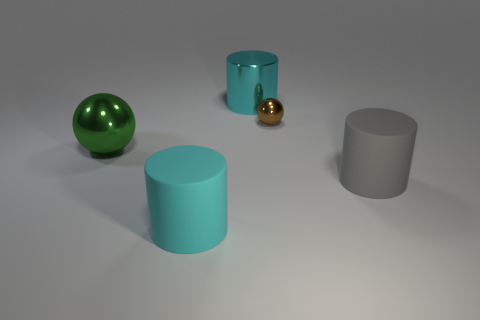What is the material of the other object that is the same shape as the tiny metal object?
Give a very brief answer. Metal. Is there any other thing of the same color as the large metallic cylinder?
Keep it short and to the point. Yes. The brown shiny object has what shape?
Provide a succinct answer. Sphere. What number of other objects are there of the same material as the large gray cylinder?
Your answer should be compact. 1. Is the gray cylinder the same size as the cyan matte object?
Your response must be concise. Yes. What is the shape of the large shiny thing on the right side of the cyan rubber object?
Provide a succinct answer. Cylinder. There is a thing to the left of the cyan cylinder that is in front of the large gray thing; what is its color?
Offer a terse response. Green. Does the large metallic thing behind the brown sphere have the same shape as the large thing right of the large cyan metallic cylinder?
Offer a terse response. Yes. There is a gray rubber thing that is the same size as the green object; what shape is it?
Your answer should be very brief. Cylinder. What is the color of the other sphere that is the same material as the tiny sphere?
Your answer should be compact. Green. 